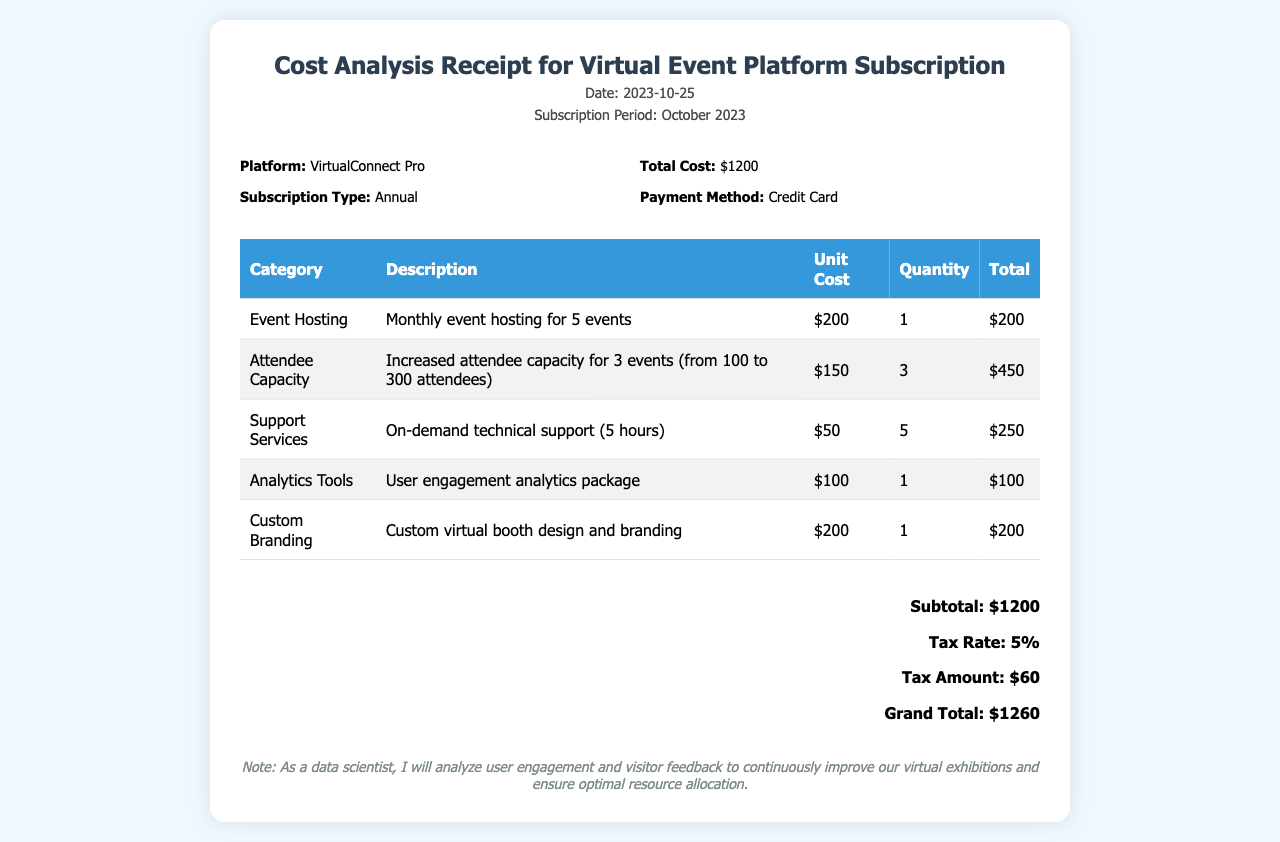what is the subscription type? The subscription type is found in the details section of the document, which states "Annual".
Answer: Annual what is the date of the receipt? The date of the receipt is indicated in the header, shown as "2023-10-25".
Answer: 2023-10-25 how many events are included in the event hosting? The document specifies that the event hosting is for "5 events".
Answer: 5 events what is the total cost before tax? The total cost before tax is shown in the summary section as "Subtotal: $1200".
Answer: $1200 what is the tax rate applied? The tax rate is detailed in the summary as "5%".
Answer: 5% how much did the support services cost? The cost for support services is detailed in the table, listed as "$250".
Answer: $250 how many hours of technical support are included? The description mentions "5 hours" for technical support in the support services section.
Answer: 5 hours what is the grand total after tax? The grand total is provided in the summary section as "Grand Total: $1260".
Answer: $1260 what platform is used for the virtual event? The platform name is mentioned in the details section as "VirtualConnect Pro".
Answer: VirtualConnect Pro 